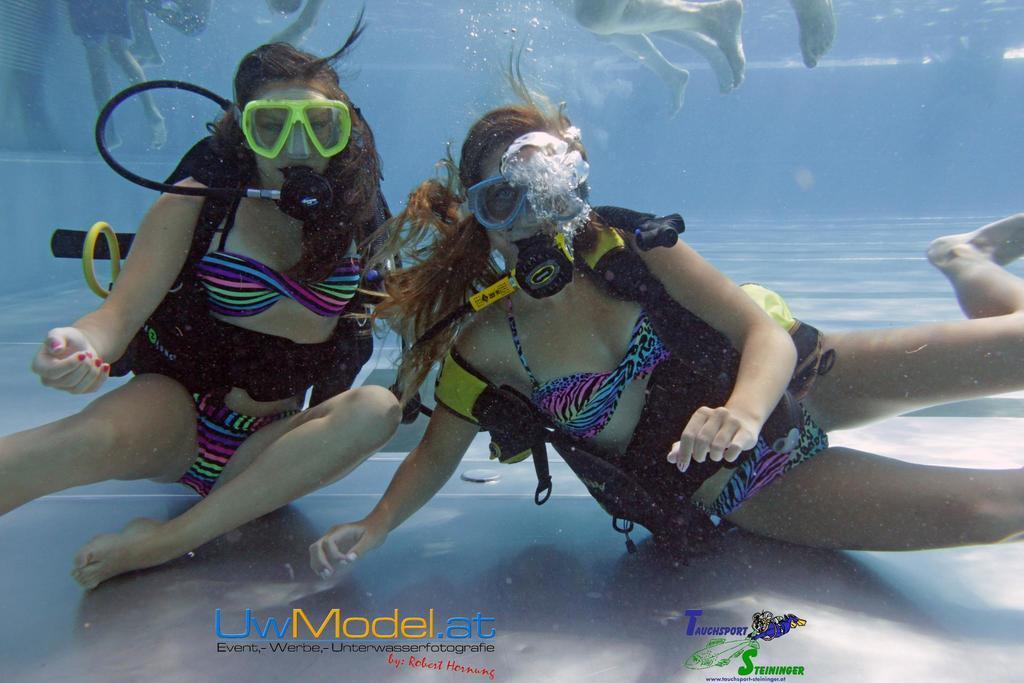How would you summarize this image in a sentence or two? This is an inside view picture in the water. In this picture we can see women wearing swimsuits and they are doing scuba diving. At the top portion of the picture we can see the legs of people. 